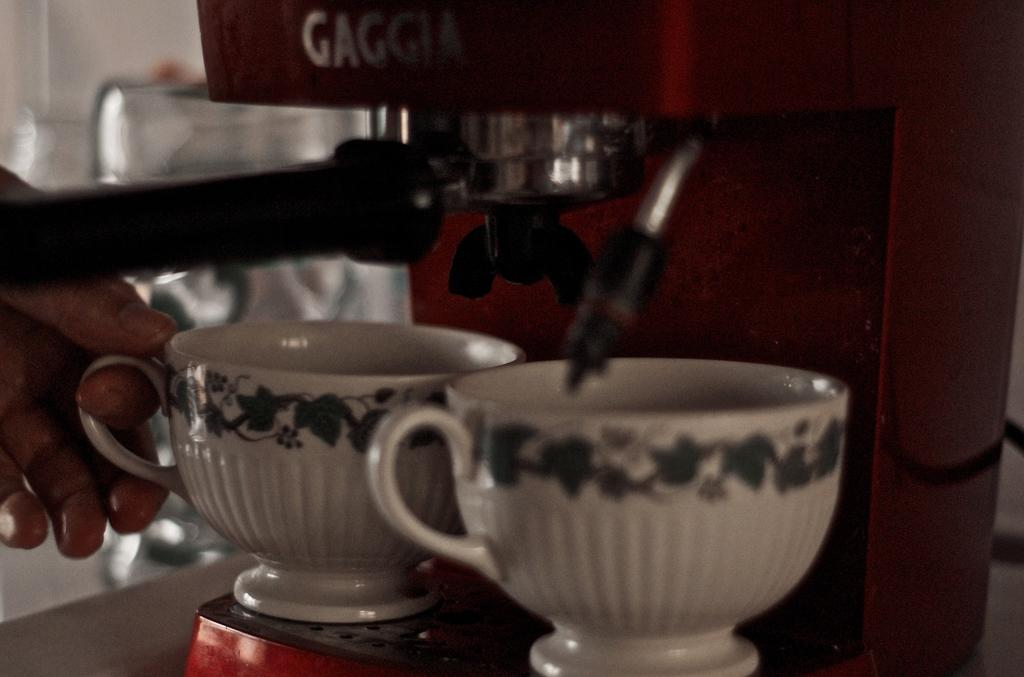What type of machine is in the image? There is a fluid machine in the image. What can be seen near the machine? There are cups and a glass container in the image. Whose hand is visible in the image? A person's hand is visible in the image. What is the background of the image? There is a wall in the image. What part of the bee can be seen in the image? There are no bees present in the image. 